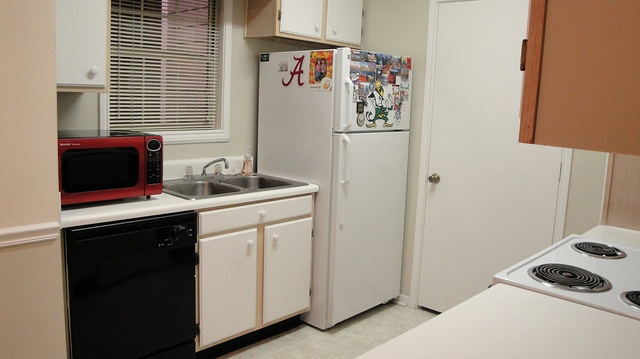Describe the objects in this image and their specific colors. I can see refrigerator in tan, darkgray, lightgray, and gray tones, oven in tan, black, and gray tones, oven in tan, darkgray, lightgray, gray, and black tones, microwave in tan, black, maroon, brown, and gray tones, and sink in tan, gray, black, and darkgray tones in this image. 